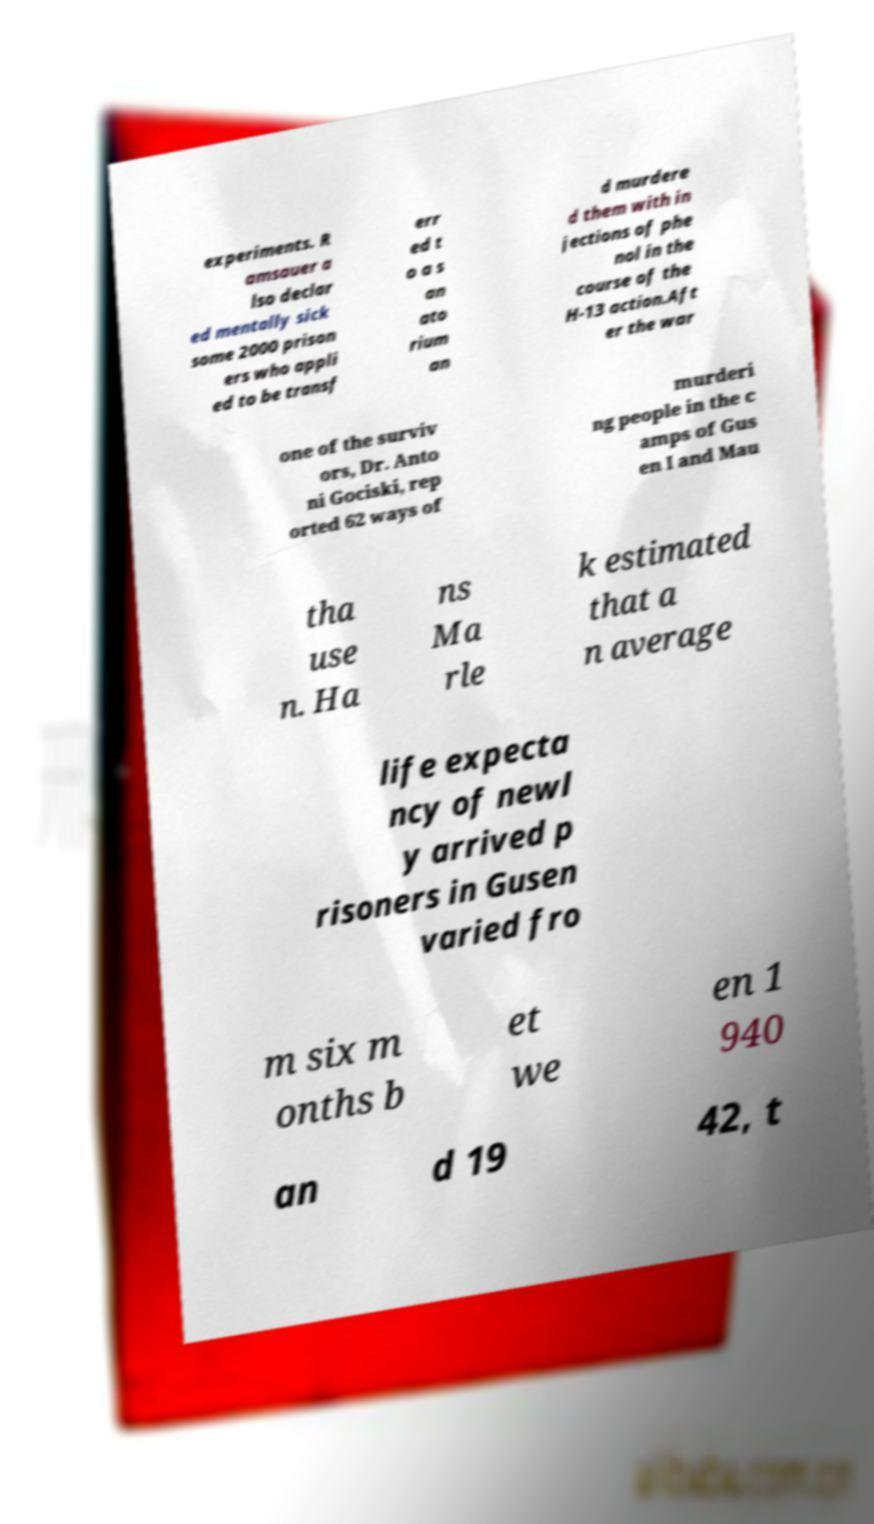Can you accurately transcribe the text from the provided image for me? experiments. R amsauer a lso declar ed mentally sick some 2000 prison ers who appli ed to be transf err ed t o a s an ato rium an d murdere d them with in jections of phe nol in the course of the H-13 action.Aft er the war one of the surviv ors, Dr. Anto ni Gociski, rep orted 62 ways of murderi ng people in the c amps of Gus en I and Mau tha use n. Ha ns Ma rle k estimated that a n average life expecta ncy of newl y arrived p risoners in Gusen varied fro m six m onths b et we en 1 940 an d 19 42, t 